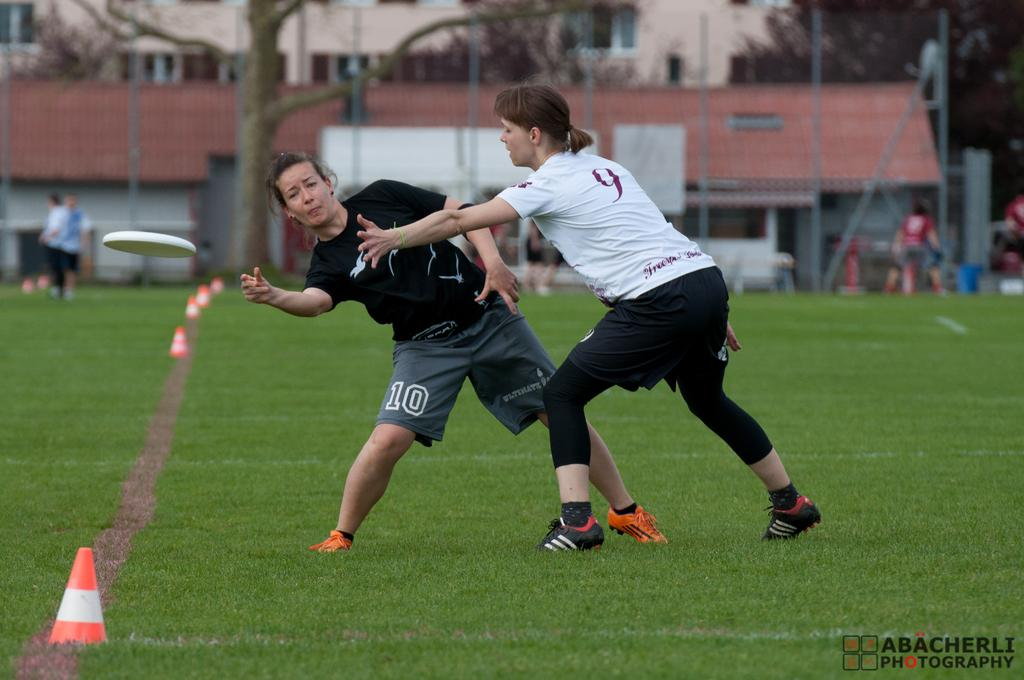What are the women in the image doing? The women in the image are playing in the center. What objects can be seen on the left side of the image? There are traffic cones on the left side of the image. What can be observed in the background of the image? Persons, trees, and houses are visible in the background. What type of jar is being used by the women in the image? There is no jar present in the image; the women are playing without any visible jar. 